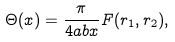<formula> <loc_0><loc_0><loc_500><loc_500>\Theta ( x ) = \frac { \pi } { 4 a b x } F ( r _ { 1 } , r _ { 2 } ) ,</formula> 